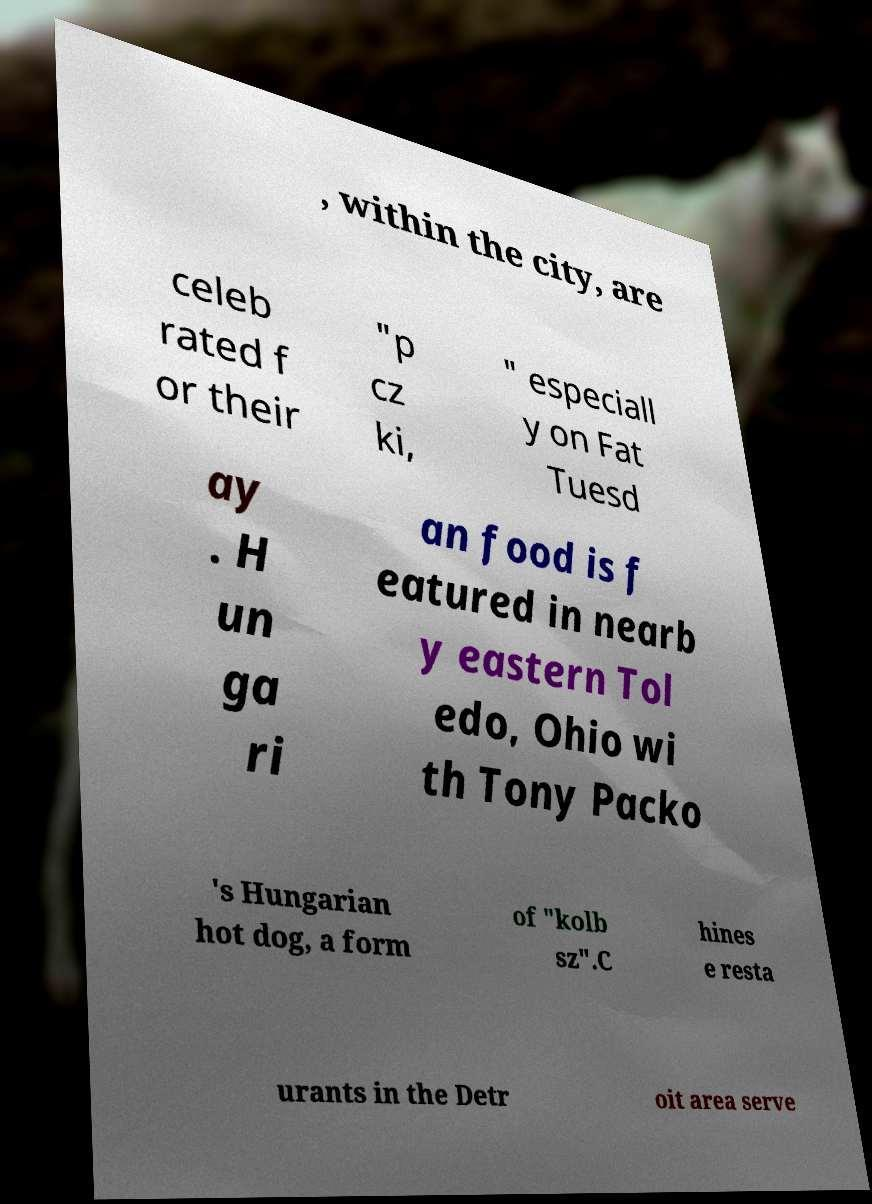There's text embedded in this image that I need extracted. Can you transcribe it verbatim? , within the city, are celeb rated f or their "p cz ki, " especiall y on Fat Tuesd ay . H un ga ri an food is f eatured in nearb y eastern Tol edo, Ohio wi th Tony Packo 's Hungarian hot dog, a form of "kolb sz".C hines e resta urants in the Detr oit area serve 